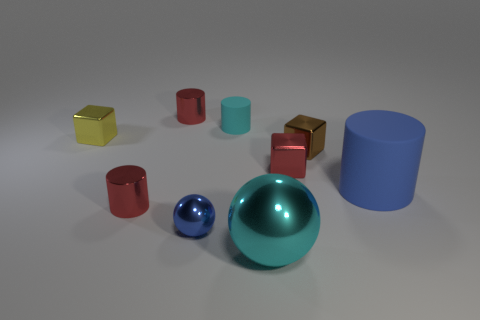Subtract all brown blocks. How many blocks are left? 2 Subtract all blue balls. How many balls are left? 1 Subtract all brown cubes. How many red cylinders are left? 2 Add 1 large blue matte cylinders. How many objects exist? 10 Subtract 3 cylinders. How many cylinders are left? 1 Subtract all cylinders. How many objects are left? 5 Add 3 red metallic cylinders. How many red metallic cylinders are left? 5 Add 2 metal cylinders. How many metal cylinders exist? 4 Subtract 0 gray spheres. How many objects are left? 9 Subtract all brown cylinders. Subtract all gray spheres. How many cylinders are left? 4 